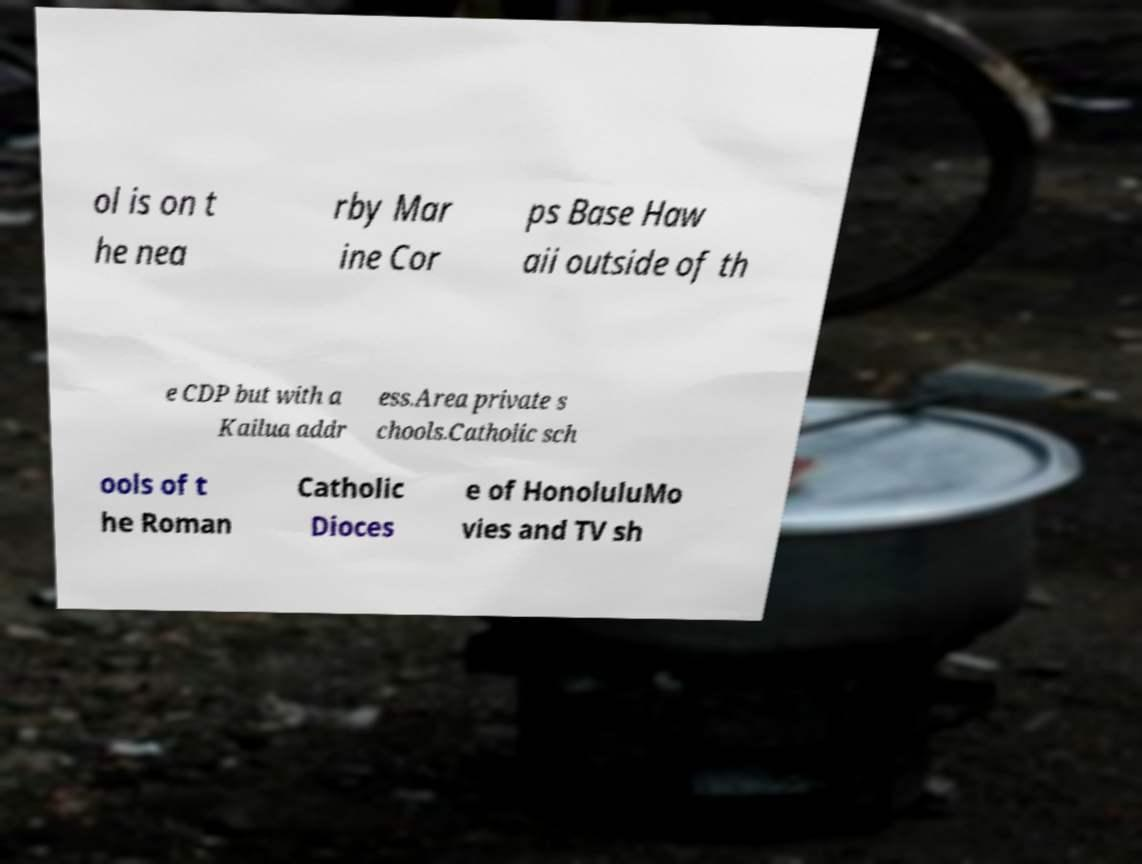Please identify and transcribe the text found in this image. ol is on t he nea rby Mar ine Cor ps Base Haw aii outside of th e CDP but with a Kailua addr ess.Area private s chools.Catholic sch ools of t he Roman Catholic Dioces e of HonoluluMo vies and TV sh 